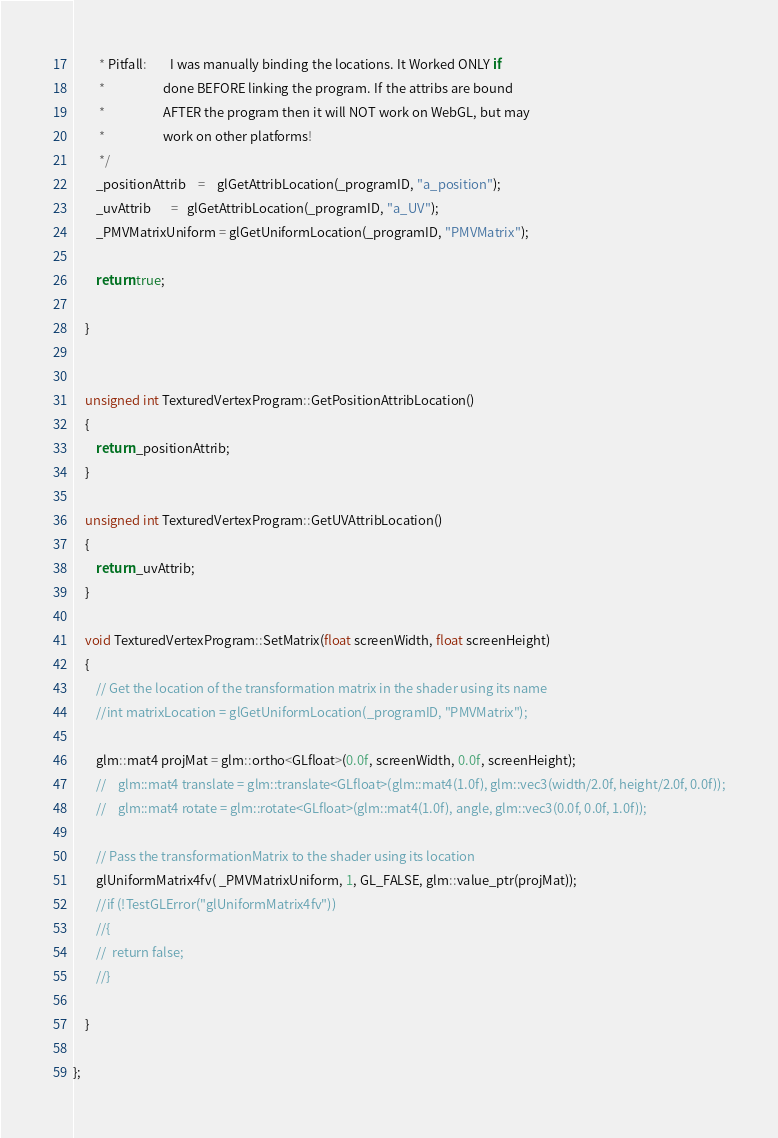Convert code to text. <code><loc_0><loc_0><loc_500><loc_500><_C++_>         * Pitfall: 		I was manually binding the locations. It Worked ONLY if
         *					done BEFORE linking the program. If the attribs are bound
         *					AFTER the program then it will NOT work on WebGL, but may
         *					work on other platforms!
         */
        _positionAttrib	=	glGetAttribLocation(_programID, "a_position");
        _uvAttrib       =   glGetAttribLocation(_programID, "a_UV");
        _PMVMatrixUniform = glGetUniformLocation(_programID, "PMVMatrix");

        return true;

    }


    unsigned int TexturedVertexProgram::GetPositionAttribLocation()
    {
        return _positionAttrib;
    }

    unsigned int TexturedVertexProgram::GetUVAttribLocation()
    {
        return _uvAttrib;
    }

    void TexturedVertexProgram::SetMatrix(float screenWidth, float screenHeight)
    {
        // Get the location of the transformation matrix in the shader using its name
        //int matrixLocation = glGetUniformLocation(_programID, "PMVMatrix");

        glm::mat4 projMat = glm::ortho<GLfloat>(0.0f, screenWidth, 0.0f, screenHeight);
        //    glm::mat4 translate = glm::translate<GLfloat>(glm::mat4(1.0f), glm::vec3(width/2.0f, height/2.0f, 0.0f));
        //    glm::mat4 rotate = glm::rotate<GLfloat>(glm::mat4(1.0f), angle, glm::vec3(0.0f, 0.0f, 1.0f));

        // Pass the transformationMatrix to the shader using its location
        glUniformMatrix4fv( _PMVMatrixUniform, 1, GL_FALSE, glm::value_ptr(projMat));
        //if (!TestGLError("glUniformMatrix4fv"))
        //{
        //	return false;
        //}

    }

};


</code> 